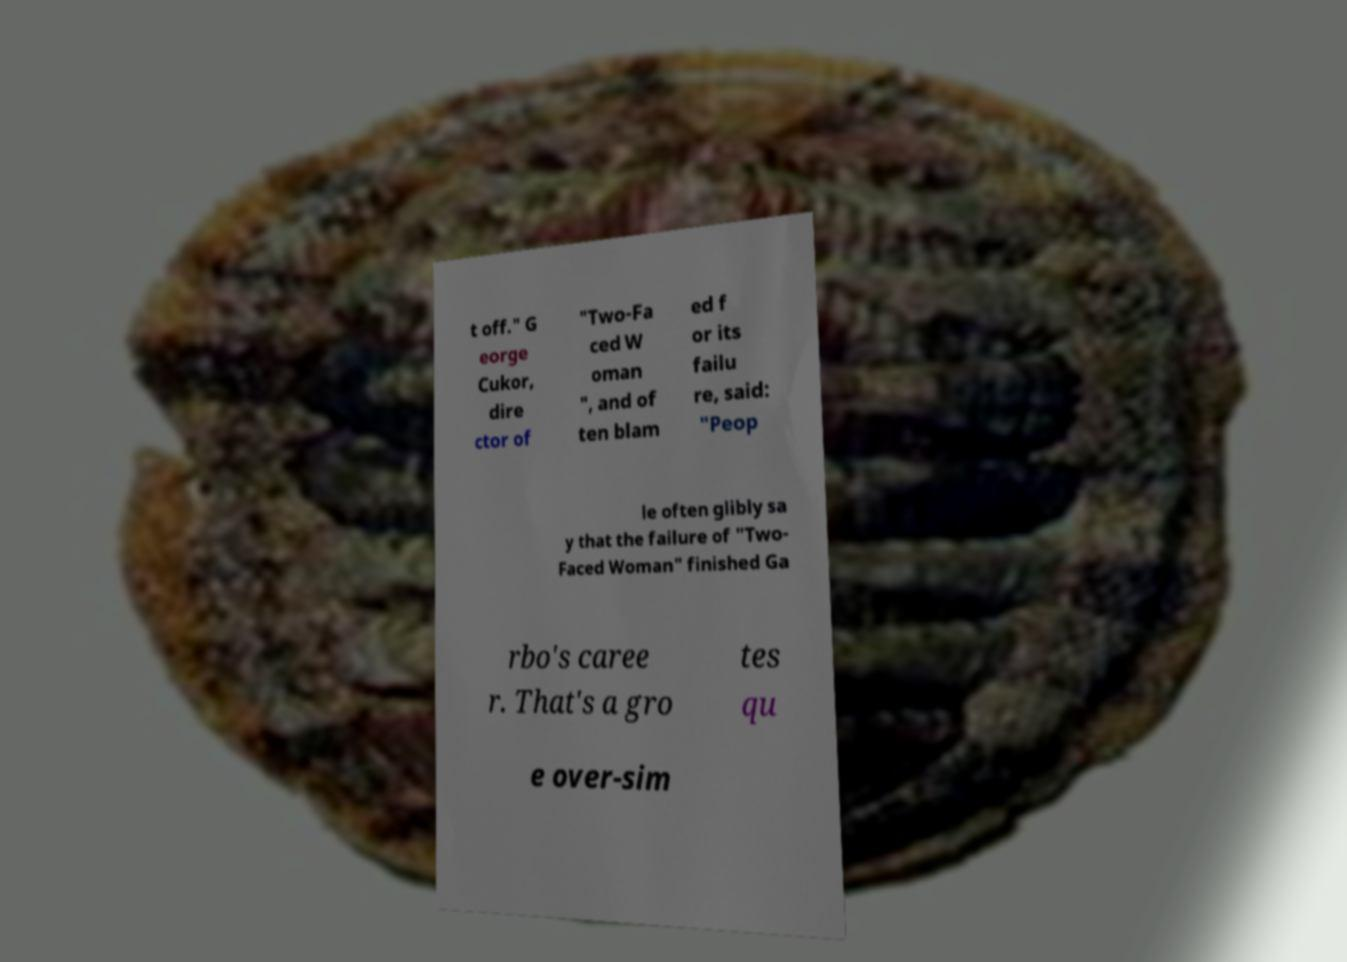Could you assist in decoding the text presented in this image and type it out clearly? t off." G eorge Cukor, dire ctor of "Two-Fa ced W oman ", and of ten blam ed f or its failu re, said: "Peop le often glibly sa y that the failure of "Two- Faced Woman" finished Ga rbo's caree r. That's a gro tes qu e over-sim 